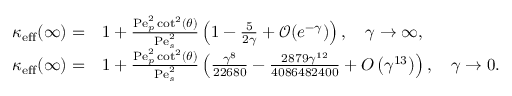<formula> <loc_0><loc_0><loc_500><loc_500>\begin{array} { r l } { \kappa _ { e f f } ( \infty ) = } & 1 + \frac { P e _ { p } ^ { 2 } \cot ^ { 2 } ( \theta ) } { P e _ { s } ^ { 2 } } \left ( 1 - \frac { 5 } { 2 \gamma } + \mathcal { O } ( e ^ { - \gamma } ) \right ) , \quad \gamma \rightarrow \infty , } \\ { \kappa _ { e f f } ( \infty ) = } & 1 + \frac { P e _ { p } ^ { 2 } \cot ^ { 2 } ( \theta ) } { P e _ { s } ^ { 2 } } \left ( \frac { \gamma ^ { 8 } } { 2 2 6 8 0 } - \frac { 2 8 7 9 \gamma ^ { 1 2 } } { 4 0 8 6 4 8 2 4 0 0 } + O \left ( \gamma ^ { 1 3 } \right ) \right ) , \quad \gamma \rightarrow 0 . } \end{array}</formula> 